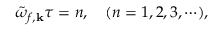<formula> <loc_0><loc_0><loc_500><loc_500>\tilde { \omega } _ { f , { k } } \tau = n , \quad ( n = 1 , 2 , 3 , \cdots ) ,</formula> 